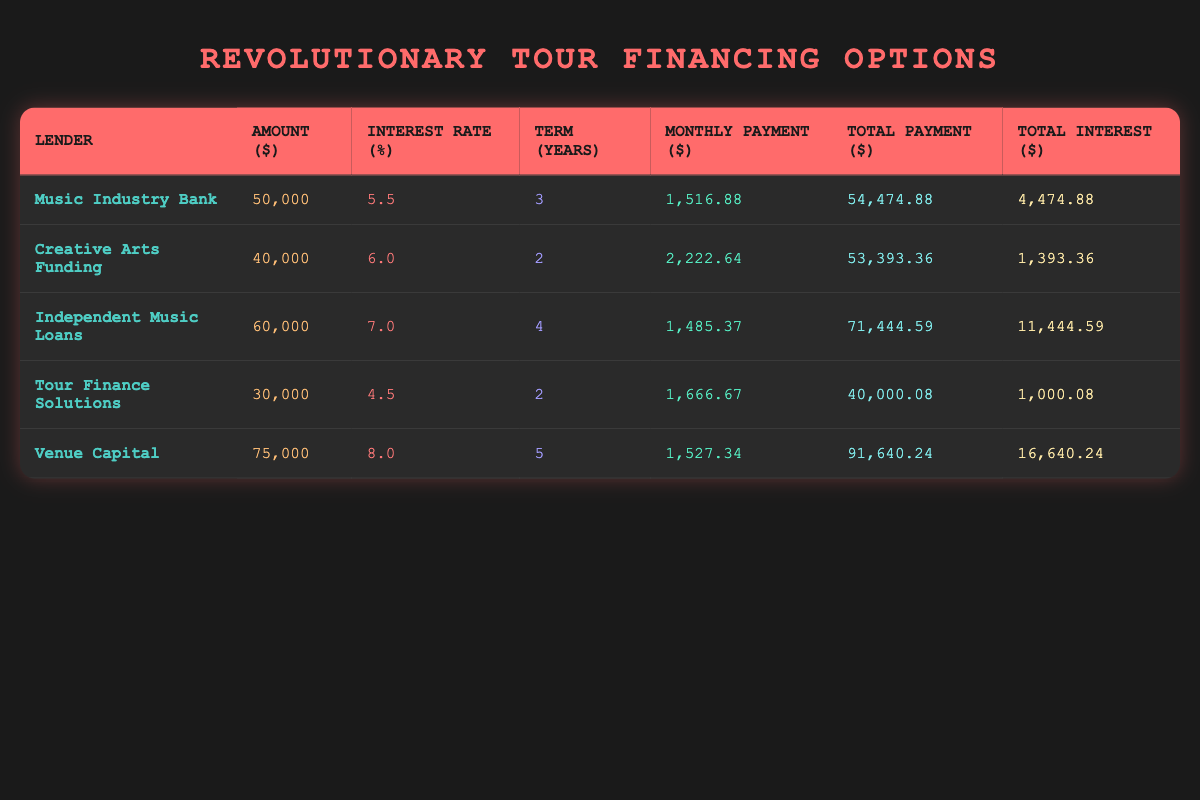What is the monthly payment for the loan from Music Industry Bank? From the table, the monthly payment for Music Industry Bank is specifically listed in the column for monthly payment. Looking at that entry, it shows 1516.88 as the value.
Answer: 1516.88 Which lender offers the lowest total interest payment? To find the lowest total interest payment, I need to compare the total interest values for each lender. The values are 4474.88, 1393.36, 11444.59, 1000.08, and 16640.24. The lowest among these is 1000.08 from Tour Finance Solutions.
Answer: 1000.08 What is the total payment for the loan from Venue Capital? The total payment for Venue Capital can be directly found in the table under the total payment column. That entry shows the total payment as 91640.24, so the answer is straightforward.
Answer: 91640.24 How much more does Independent Music Loans charge in total interest compared to Creative Arts Funding? I need to find the total interest for both lenders. Independent Music Loans has a total interest of 11444.59, and Creative Arts Funding has 1393.36. I then subtract the two values: 11444.59 - 1393.36 = 10051.23 to find the difference.
Answer: 10051.23 Is the interest rate for Tour Finance Solutions higher than that of Music Industry Bank? I compare the interest rates of both lenders. Tour Finance Solutions has an interest rate of 4.5%, while Music Industry Bank's is at 5.5%. Since 4.5% is less than 5.5%, the answer is no.
Answer: No If you take the loan from Creative Arts Funding, what is the remaining amount to be paid after the first year? First, I calculate the total payment from Creative Arts Funding which is 53393.36, and then divide this by the term of 2 years to find the yearly payment: 53393.36 / 2 = 26696.68. After the first year, the remaining amount will be the total payment minus the first year's payment: 53393.36 - 26696.68 = 26696.68.
Answer: 26696.68 What percentage of the total amount borrowed does the total payment represent for Independent Music Loans? For Independent Music Loans, the amount borrowed is 60000, and the total payment is 71444.59. Thus, I calculate the percentage: (71444.59 / 60000) * 100. The calculation results in approximately 119.07%.
Answer: 119.07% Which loan term has the highest monthly payment? To determine which loan term has the highest monthly payment, I check the monthly payments in the table: 1516.88, 2222.64, 1485.37, 1666.67, and 1527.34. The maximum among these is 2222.64 from Creative Arts Funding.
Answer: 2222.64 